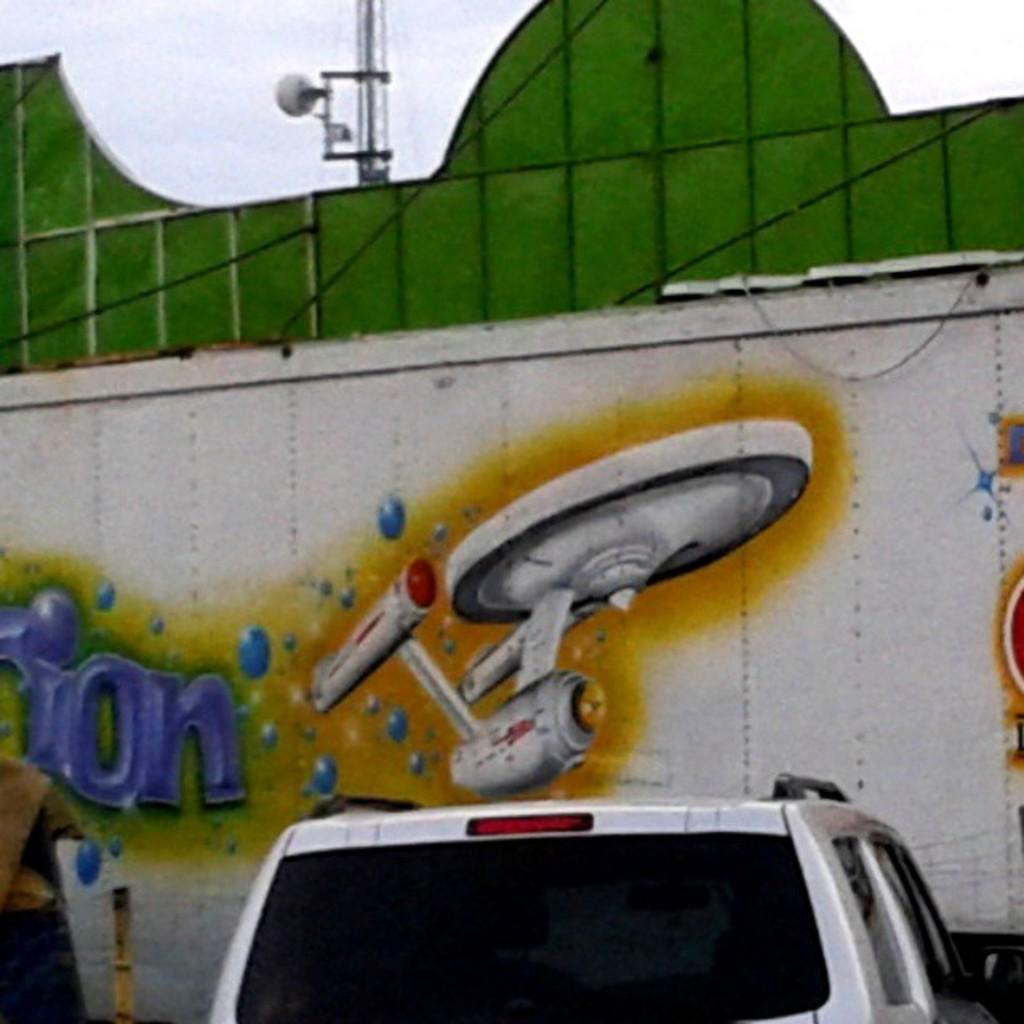What is the main subject of the image? The main subject of the image is a car. What else can be seen in the image besides the car? There is a wall in the image. What is on the wall? A painting is made on the wall. How many plants are visible in the image? There are no plants visible in the image. What type of cattle can be seen grazing near the car in the image? There are no cattle present in the image. 